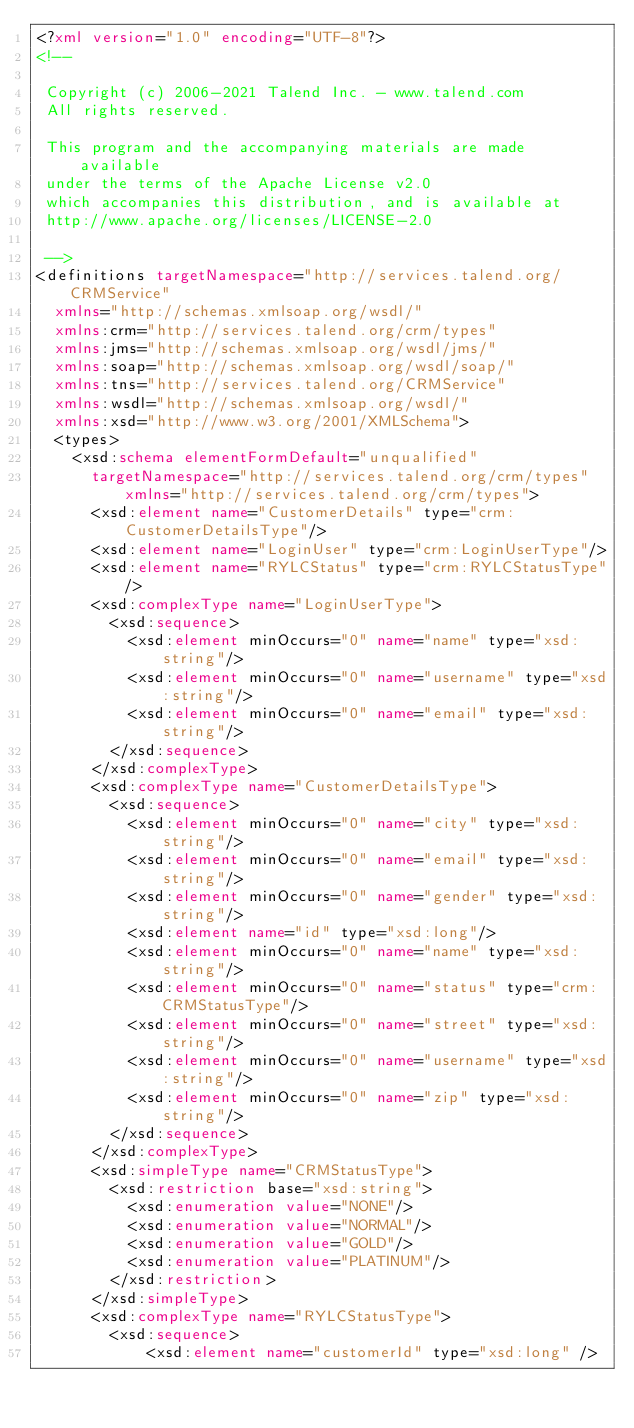<code> <loc_0><loc_0><loc_500><loc_500><_XML_><?xml version="1.0" encoding="UTF-8"?>
<!--

 Copyright (c) 2006-2021 Talend Inc. - www.talend.com
 All rights reserved.

 This program and the accompanying materials are made available
 under the terms of the Apache License v2.0
 which accompanies this distribution, and is available at
 http://www.apache.org/licenses/LICENSE-2.0

 -->
<definitions targetNamespace="http://services.talend.org/CRMService"
  xmlns="http://schemas.xmlsoap.org/wsdl/"
  xmlns:crm="http://services.talend.org/crm/types"
  xmlns:jms="http://schemas.xmlsoap.org/wsdl/jms/"
  xmlns:soap="http://schemas.xmlsoap.org/wsdl/soap/"
  xmlns:tns="http://services.talend.org/CRMService"
  xmlns:wsdl="http://schemas.xmlsoap.org/wsdl/"
  xmlns:xsd="http://www.w3.org/2001/XMLSchema">
  <types>
    <xsd:schema elementFormDefault="unqualified"
      targetNamespace="http://services.talend.org/crm/types" xmlns="http://services.talend.org/crm/types">
      <xsd:element name="CustomerDetails" type="crm:CustomerDetailsType"/>
      <xsd:element name="LoginUser" type="crm:LoginUserType"/>
      <xsd:element name="RYLCStatus" type="crm:RYLCStatusType"/>
      <xsd:complexType name="LoginUserType">
        <xsd:sequence>
          <xsd:element minOccurs="0" name="name" type="xsd:string"/>
          <xsd:element minOccurs="0" name="username" type="xsd:string"/>
          <xsd:element minOccurs="0" name="email" type="xsd:string"/>
        </xsd:sequence>
      </xsd:complexType>
      <xsd:complexType name="CustomerDetailsType">
        <xsd:sequence>
          <xsd:element minOccurs="0" name="city" type="xsd:string"/>
          <xsd:element minOccurs="0" name="email" type="xsd:string"/>
          <xsd:element minOccurs="0" name="gender" type="xsd:string"/>
          <xsd:element name="id" type="xsd:long"/>
          <xsd:element minOccurs="0" name="name" type="xsd:string"/>
          <xsd:element minOccurs="0" name="status" type="crm:CRMStatusType"/>
          <xsd:element minOccurs="0" name="street" type="xsd:string"/>
          <xsd:element minOccurs="0" name="username" type="xsd:string"/>
          <xsd:element minOccurs="0" name="zip" type="xsd:string"/>
        </xsd:sequence>
      </xsd:complexType>
      <xsd:simpleType name="CRMStatusType">
        <xsd:restriction base="xsd:string">
          <xsd:enumeration value="NONE"/>
          <xsd:enumeration value="NORMAL"/>
          <xsd:enumeration value="GOLD"/>
          <xsd:enumeration value="PLATINUM"/>
        </xsd:restriction>
      </xsd:simpleType>
      <xsd:complexType name="RYLCStatusType">
        <xsd:sequence>
            <xsd:element name="customerId" type="xsd:long" /></code> 